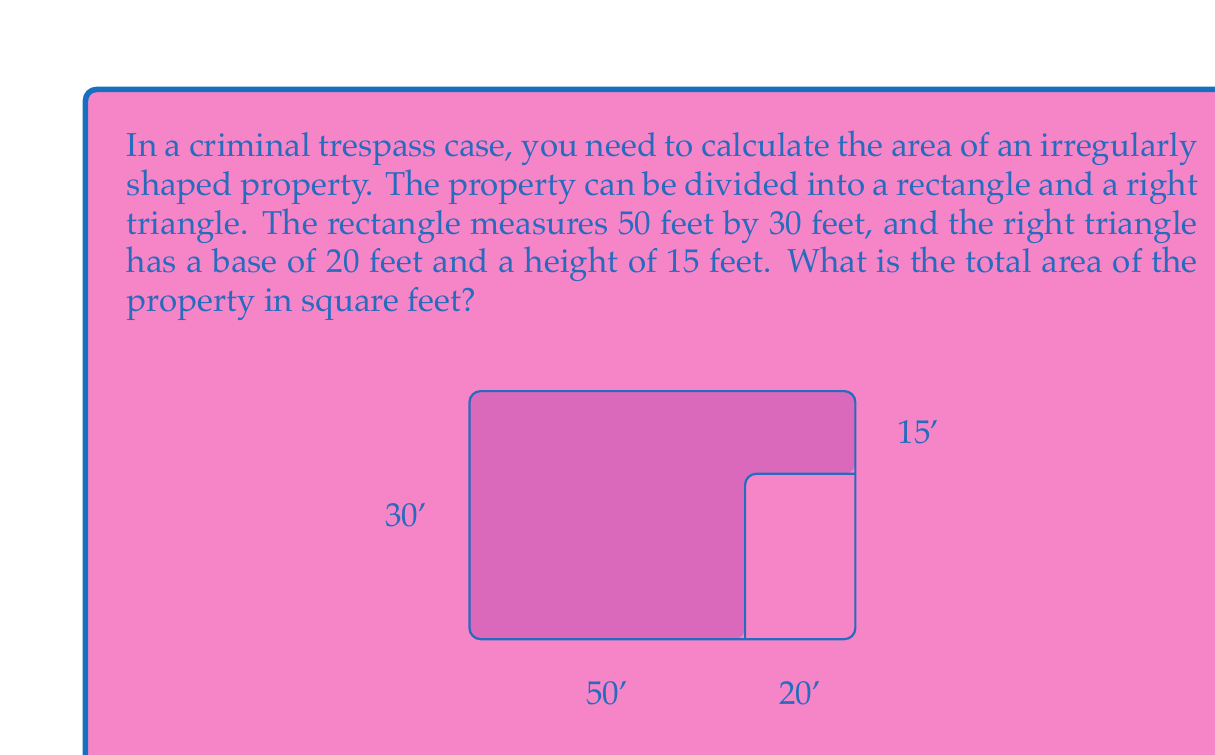Help me with this question. To solve this problem, we need to calculate the areas of the rectangle and the right triangle separately, then add them together.

1. Calculate the area of the rectangle:
   $A_{rectangle} = length \times width$
   $A_{rectangle} = 50 \text{ ft} \times 30 \text{ ft} = 1500 \text{ sq ft}$

2. Calculate the area of the right triangle:
   $A_{triangle} = \frac{1}{2} \times base \times height$
   $A_{triangle} = \frac{1}{2} \times 20 \text{ ft} \times 15 \text{ ft} = 150 \text{ sq ft}$

3. Sum up the areas to get the total area of the property:
   $A_{total} = A_{rectangle} + A_{triangle}$
   $A_{total} = 1500 \text{ sq ft} + 150 \text{ sq ft} = 1650 \text{ sq ft}$

Therefore, the total area of the irregularly shaped property is 1650 square feet.
Answer: 1650 sq ft 